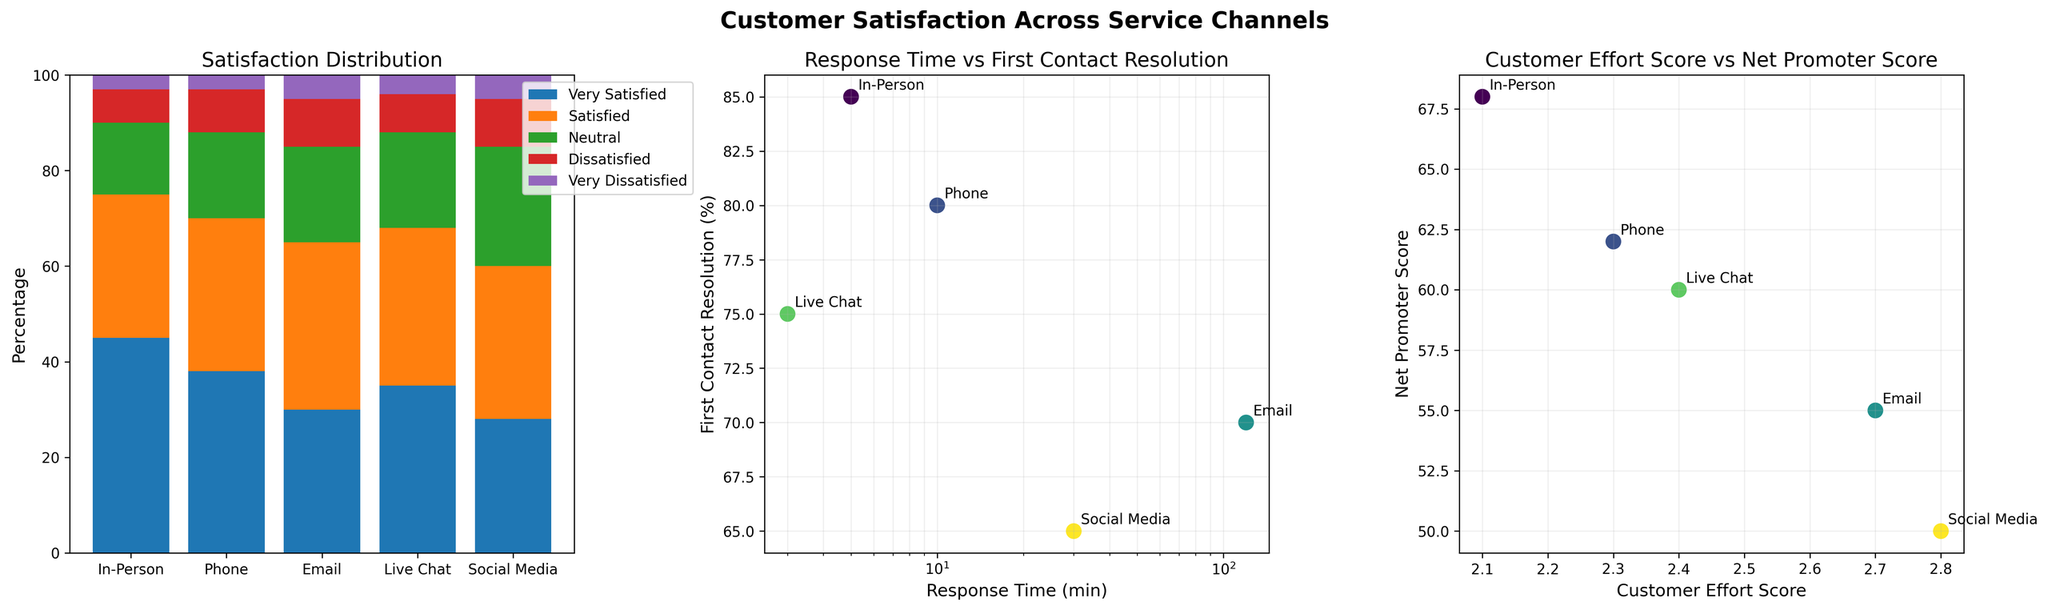What's the highest satisfaction percentage for any channel? Looking at the Satisfaction Distribution plot, the highest percentage is for "In-Person" under "Very Satisfied", which is 45%.
Answer: 45% Which service channel shows the longest response time and the lowest first contact resolution? Refer to the Response Time vs First Contact Resolution plot, we see that "Email" channel has the longest response time (120 min) and the lowest first contact resolution (70%).
Answer: Email Is the net promoter score higher for channels with lower or higher customer effort scores? Observing the Customer Effort Score vs Net Promoter Score plot, channels with lower customer effort scores (e.g., In-Person with 2.1) have higher net promoter scores (e.g., In-Person with 68).
Answer: Lower What's the combined percentage of dissatisfied and very dissatisfied customers for Live Chat? In the Satisfaction Distribution plot, sum the percentages for "Dissatisfied" (8%) and "Very Dissatisfied" (4%) in the "Live Chat" channel.
Answer: 12% Does the In-Person channel have a higher or lower repeat contact rate compared to Social Media? From the additional metrics, the Repeat Contact Rate for "In-Person" is 12%, whereas for "Social Media" it is 20%.
Answer: Lower 